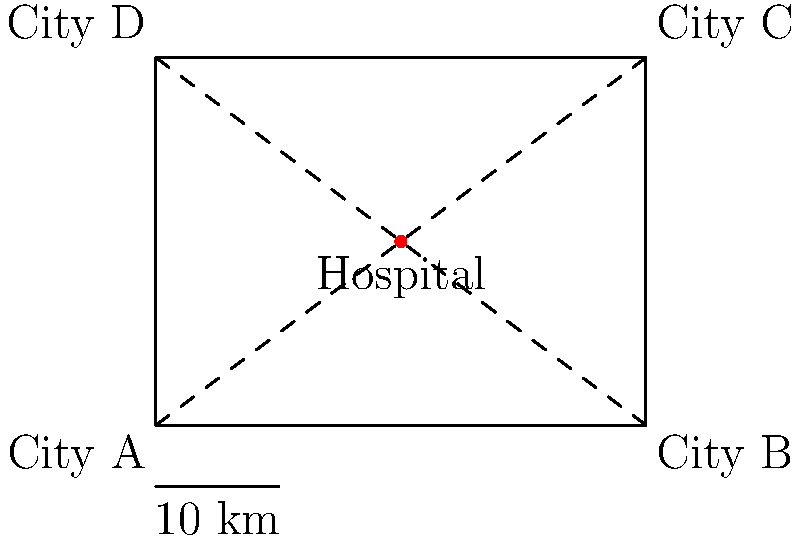A new hospital is being built to serve four cities (A, B, C, and D) in a rural area. The hospital's location $(x,y)$ has been chosen to minimize the sum of the squared distances from the hospital to each city. Given that the cities are located at $(0,0)$, $(4,0)$, $(4,3)$, and $(0,3)$ respectively on a map where each unit represents 10 km, and the hospital is placed at $(2,1.5)$, calculate the total squared distance from the hospital to all four cities. How would changing the hospital's location affect this total? Let's approach this step-by-step:

1) The distance formula in two dimensions is:
   $d = \sqrt{(x_2-x_1)^2 + (y_2-y_1)^2}$

2) We need to calculate the squared distance, so we'll use:
   $d^2 = (x_2-x_1)^2 + (y_2-y_1)^2$

3) Let's calculate the squared distance from the hospital $(2,1.5)$ to each city:

   City A $(0,0)$: $d_A^2 = (2-0)^2 + (1.5-0)^2 = 4 + 2.25 = 6.25$
   City B $(4,0)$: $d_B^2 = (2-4)^2 + (1.5-0)^2 = 4 + 2.25 = 6.25$
   City C $(4,3)$: $d_C^2 = (2-4)^2 + (1.5-3)^2 = 4 + 2.25 = 6.25$
   City D $(0,3)$: $d_D^2 = (2-0)^2 + (1.5-3)^2 = 4 + 2.25 = 6.25$

4) The total squared distance is the sum of these:
   $\text{Total} = 6.25 + 6.25 + 6.25 + 6.25 = 25$

5) Since each unit on the map represents 10 km, the actual total squared distance is:
   $25 * 10^2 = 2500 \text{ km}^2$

6) Changing the hospital's location would affect this total. The current location $(2,1.5)$ is optimal because:
   - It's at the center of the square formed by the four cities.
   - Moving in any direction would decrease the distance to some cities but increase it for others.
   - The sum of squared distances would increase for any other location.

This can be proven using calculus by finding the minimum of the function:
$f(x,y) = (x-0)^2 + (y-0)^2 + (x-4)^2 + (y-0)^2 + (x-4)^2 + (y-3)^2 + (x-0)^2 + (y-3)^2$

The minimum occurs where $\frac{\partial f}{\partial x} = \frac{\partial f}{\partial y} = 0$, which gives $x=2$ and $y=1.5$.
Answer: 2500 km²; any change increases the total. 